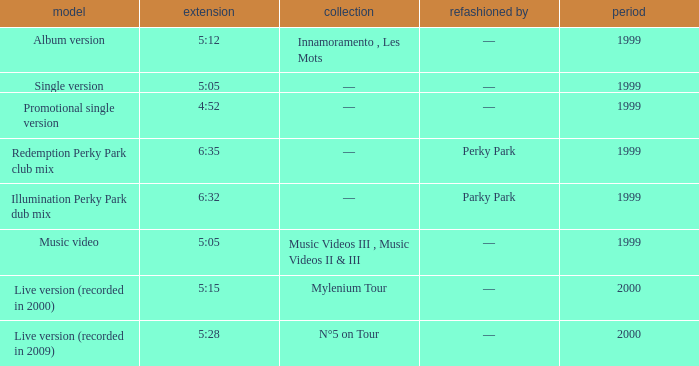What album is 5:15 long Live version (recorded in 2000). Could you help me parse every detail presented in this table? {'header': ['model', 'extension', 'collection', 'refashioned by', 'period'], 'rows': [['Album version', '5:12', 'Innamoramento , Les Mots', '—', '1999'], ['Single version', '5:05', '—', '—', '1999'], ['Promotional single version', '4:52', '—', '—', '1999'], ['Redemption Perky Park club mix', '6:35', '—', 'Perky Park', '1999'], ['Illumination Perky Park dub mix', '6:32', '—', 'Parky Park', '1999'], ['Music video', '5:05', 'Music Videos III , Music Videos II & III', '—', '1999'], ['Live version (recorded in 2000)', '5:15', 'Mylenium Tour', '—', '2000'], ['Live version (recorded in 2009)', '5:28', 'N°5 on Tour', '—', '2000']]} 